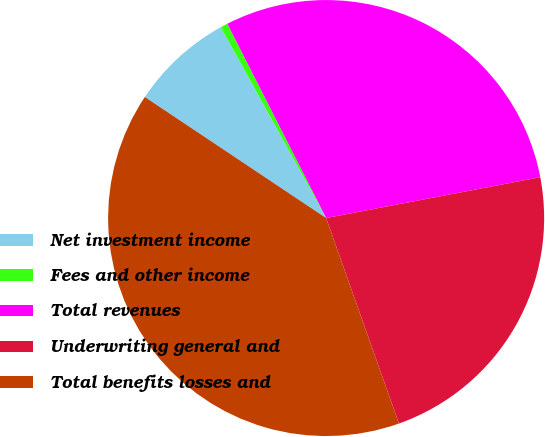Convert chart to OTSL. <chart><loc_0><loc_0><loc_500><loc_500><pie_chart><fcel>Net investment income<fcel>Fees and other income<fcel>Total revenues<fcel>Underwriting general and<fcel>Total benefits losses and<nl><fcel>7.6%<fcel>0.54%<fcel>29.49%<fcel>22.58%<fcel>39.79%<nl></chart> 